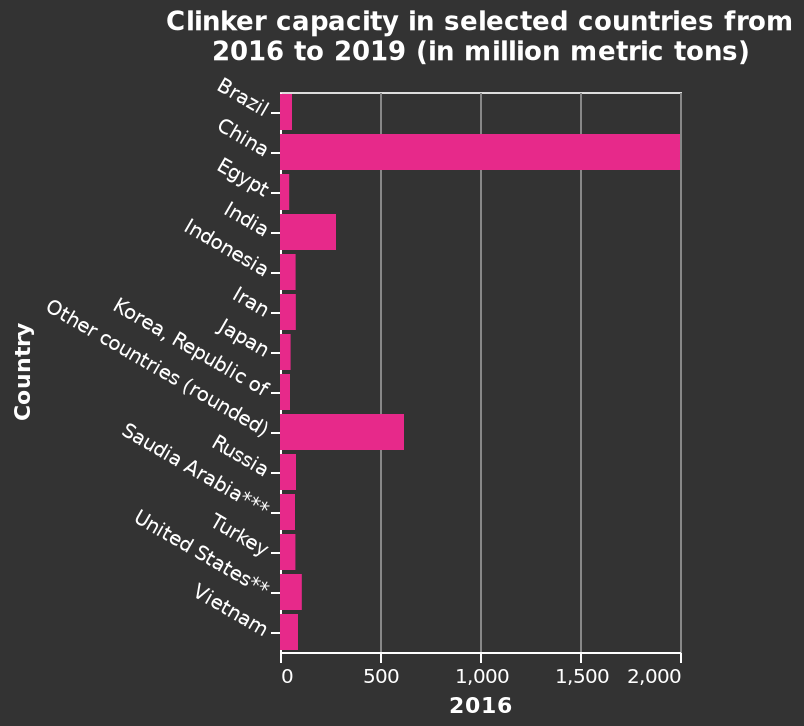<image>
What does the x-axis measure on the bar graph? The x-axis measures the years from 2016 to 2019 using a linear scale ranging from 0 to 2,000. Which country is located at one end of the y-axis? Brazil is located at one end of the y-axis. 